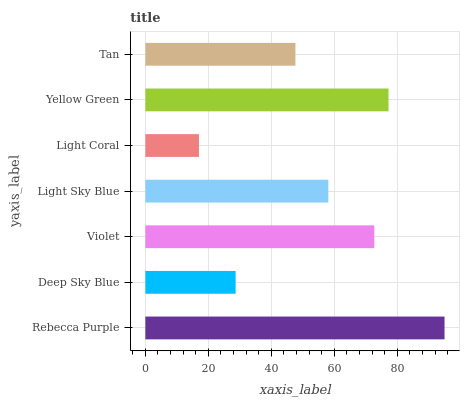Is Light Coral the minimum?
Answer yes or no. Yes. Is Rebecca Purple the maximum?
Answer yes or no. Yes. Is Deep Sky Blue the minimum?
Answer yes or no. No. Is Deep Sky Blue the maximum?
Answer yes or no. No. Is Rebecca Purple greater than Deep Sky Blue?
Answer yes or no. Yes. Is Deep Sky Blue less than Rebecca Purple?
Answer yes or no. Yes. Is Deep Sky Blue greater than Rebecca Purple?
Answer yes or no. No. Is Rebecca Purple less than Deep Sky Blue?
Answer yes or no. No. Is Light Sky Blue the high median?
Answer yes or no. Yes. Is Light Sky Blue the low median?
Answer yes or no. Yes. Is Yellow Green the high median?
Answer yes or no. No. Is Violet the low median?
Answer yes or no. No. 